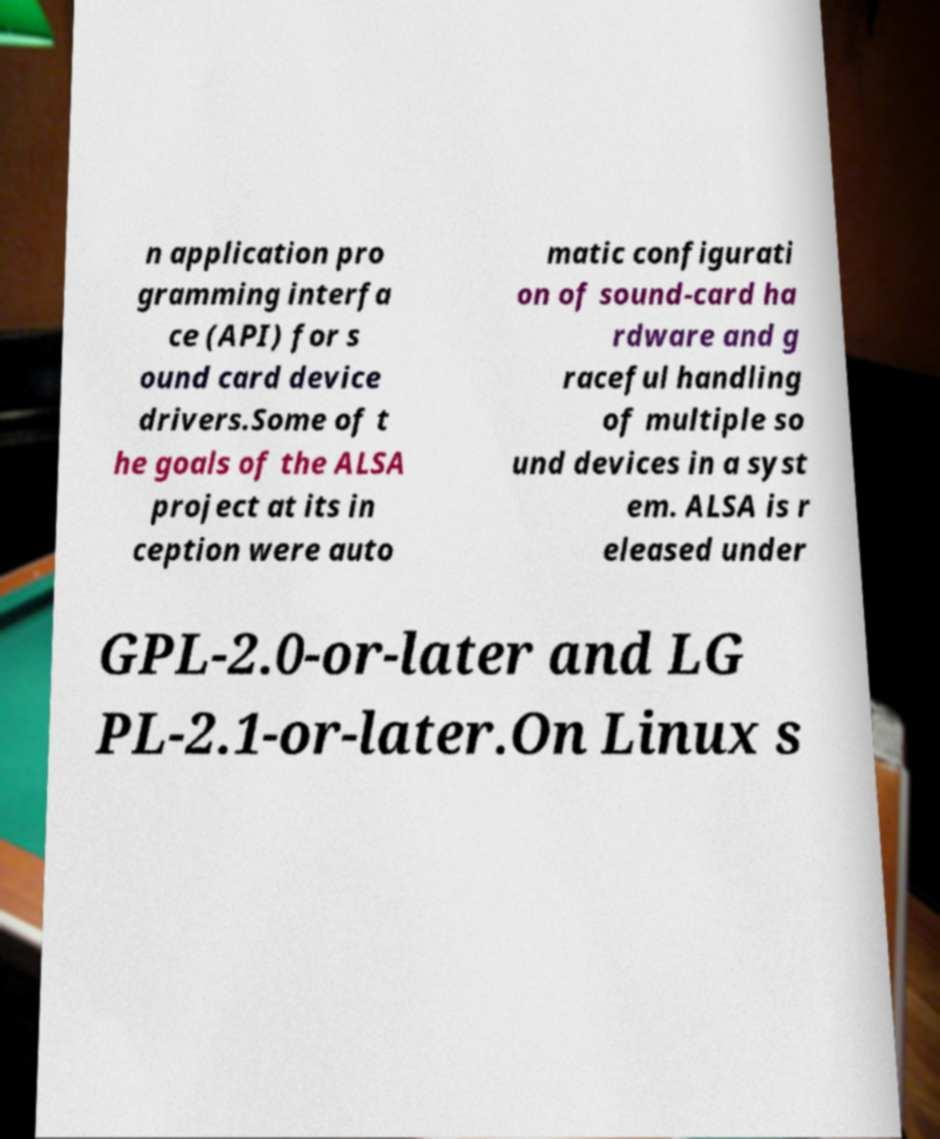There's text embedded in this image that I need extracted. Can you transcribe it verbatim? n application pro gramming interfa ce (API) for s ound card device drivers.Some of t he goals of the ALSA project at its in ception were auto matic configurati on of sound-card ha rdware and g raceful handling of multiple so und devices in a syst em. ALSA is r eleased under GPL-2.0-or-later and LG PL-2.1-or-later.On Linux s 